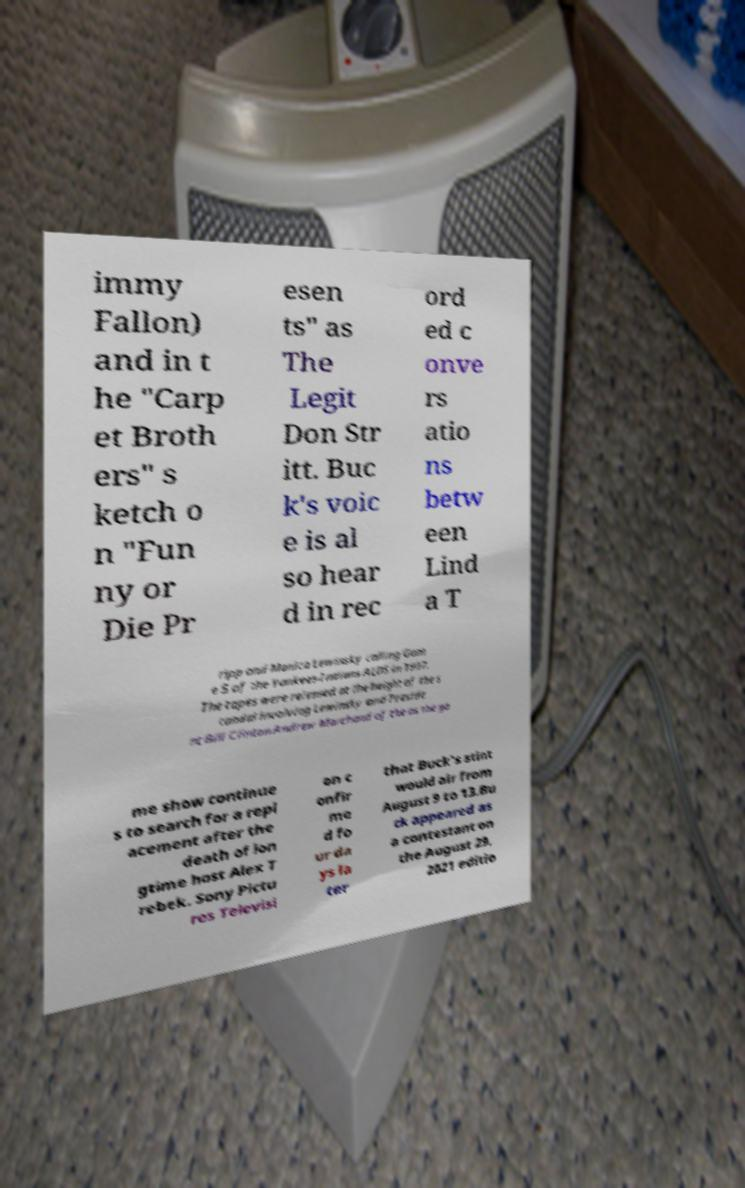Please read and relay the text visible in this image. What does it say? immy Fallon) and in t he "Carp et Broth ers" s ketch o n "Fun ny or Die Pr esen ts" as The Legit Don Str itt. Buc k's voic e is al so hear d in rec ord ed c onve rs atio ns betw een Lind a T ripp and Monica Lewinsky calling Gam e 5 of the Yankees-Indians ALDS in 1997. The tapes were released at the height of the s candal involving Lewinsky and Preside nt Bill Clinton.Andrew Marchand of the as the ga me show continue s to search for a repl acement after the death of lon gtime host Alex T rebek. Sony Pictu res Televisi on c onfir me d fo ur da ys la ter that Buck's stint would air from August 9 to 13.Bu ck appeared as a contestant on the August 29, 2021 editio 